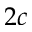<formula> <loc_0><loc_0><loc_500><loc_500>2 c</formula> 